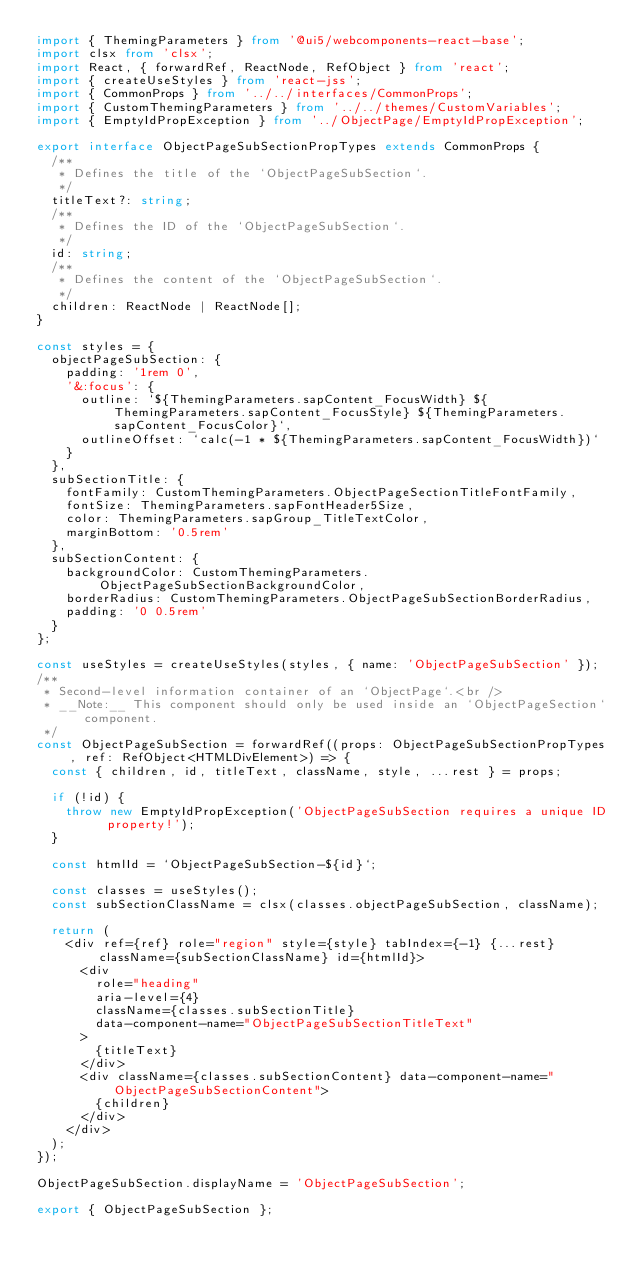Convert code to text. <code><loc_0><loc_0><loc_500><loc_500><_TypeScript_>import { ThemingParameters } from '@ui5/webcomponents-react-base';
import clsx from 'clsx';
import React, { forwardRef, ReactNode, RefObject } from 'react';
import { createUseStyles } from 'react-jss';
import { CommonProps } from '../../interfaces/CommonProps';
import { CustomThemingParameters } from '../../themes/CustomVariables';
import { EmptyIdPropException } from '../ObjectPage/EmptyIdPropException';

export interface ObjectPageSubSectionPropTypes extends CommonProps {
  /**
   * Defines the title of the `ObjectPageSubSection`.
   */
  titleText?: string;
  /**
   * Defines the ID of the `ObjectPageSubSection`.
   */
  id: string;
  /**
   * Defines the content of the `ObjectPageSubSection`.
   */
  children: ReactNode | ReactNode[];
}

const styles = {
  objectPageSubSection: {
    padding: '1rem 0',
    '&:focus': {
      outline: `${ThemingParameters.sapContent_FocusWidth} ${ThemingParameters.sapContent_FocusStyle} ${ThemingParameters.sapContent_FocusColor}`,
      outlineOffset: `calc(-1 * ${ThemingParameters.sapContent_FocusWidth})`
    }
  },
  subSectionTitle: {
    fontFamily: CustomThemingParameters.ObjectPageSectionTitleFontFamily,
    fontSize: ThemingParameters.sapFontHeader5Size,
    color: ThemingParameters.sapGroup_TitleTextColor,
    marginBottom: '0.5rem'
  },
  subSectionContent: {
    backgroundColor: CustomThemingParameters.ObjectPageSubSectionBackgroundColor,
    borderRadius: CustomThemingParameters.ObjectPageSubSectionBorderRadius,
    padding: '0 0.5rem'
  }
};

const useStyles = createUseStyles(styles, { name: 'ObjectPageSubSection' });
/**
 * Second-level information container of an `ObjectPage`.<br />
 * __Note:__ This component should only be used inside an `ObjectPageSection` component.
 */
const ObjectPageSubSection = forwardRef((props: ObjectPageSubSectionPropTypes, ref: RefObject<HTMLDivElement>) => {
  const { children, id, titleText, className, style, ...rest } = props;

  if (!id) {
    throw new EmptyIdPropException('ObjectPageSubSection requires a unique ID property!');
  }

  const htmlId = `ObjectPageSubSection-${id}`;

  const classes = useStyles();
  const subSectionClassName = clsx(classes.objectPageSubSection, className);

  return (
    <div ref={ref} role="region" style={style} tabIndex={-1} {...rest} className={subSectionClassName} id={htmlId}>
      <div
        role="heading"
        aria-level={4}
        className={classes.subSectionTitle}
        data-component-name="ObjectPageSubSectionTitleText"
      >
        {titleText}
      </div>
      <div className={classes.subSectionContent} data-component-name="ObjectPageSubSectionContent">
        {children}
      </div>
    </div>
  );
});

ObjectPageSubSection.displayName = 'ObjectPageSubSection';

export { ObjectPageSubSection };
</code> 